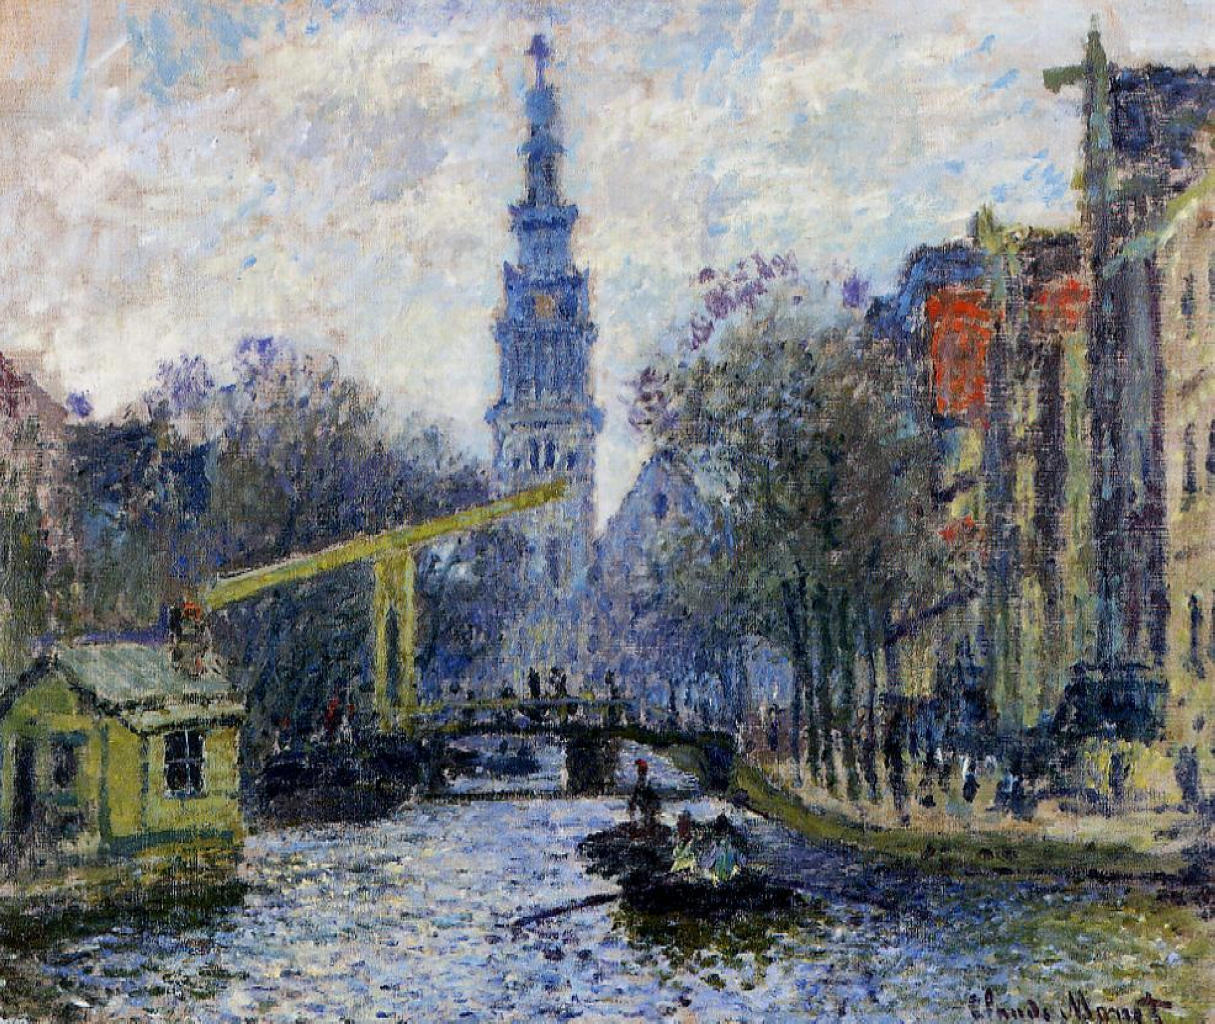Can you elaborate on the historical context of this painting? This painting by Claude Monet belongs to the impressionist movement, which originated in France in the late 19th century. Impressionism was characterized by a focus on capturing the effects of light and color rather than precise detail. Monet, one of the leading figures in this movement, painted numerous cityscapes, often depicting urban landscapes with bustling life and changing atmospheric conditions. This particular painting shows his fascination with capturing fleeting moments and the beauty of everyday scenes. The bridge and canal depicted here likely reflect the urban transformation and modernization during that period, a common theme among impressionist painters. The cityscape suggests a sense of calm and tranquility amidst the ongoing changes of that era. What might Monet have been thinking while creating this artwork? Monet was likely focused on how best to capture the transient qualities of light and color when creating this artwork. He aimed to convey the atmosphere and mood of the cityscape rather than its exact details. Monet’s goal was to evoke the viewer's emotional response rather than provide a literal representation. His choice of colors and brushstrokes reflects an endeavor to freeze a moment in time, capturing the serenity, movement, and harmony inherent in the scene. Monet’s attention to reflections in the water, the play of light, and the overall composition showcases his fascination with the changing qualities of his surroundings, a central theme in his work. If this painting were a scene in a movie, what kind of story would it tell? Imagine this painting as the opening scene of a movie set in a bustling European city during the late 19th century. A gentle sunrise illuminates the serene cityscape as people begin their day. The canal, a central lifeline of the city, is abuzz with activity: boatmen ready their vessels, pedestrians stroll across the bridge on their way to work, and shopkeepers open their stores lining the water's edge. The film could follow the intertwining lives of various characters whose paths cross on the bridge and by the canal, including a young artist inspired by Monet’s style, a family navigating urban modernization, and traders reliant on the canal’s commerce. As the movie progresses, the audience witnesses the transformation of the city and its people, all encapsulated in the atmospheric beauty and vibrancy of Monet’s painting. 